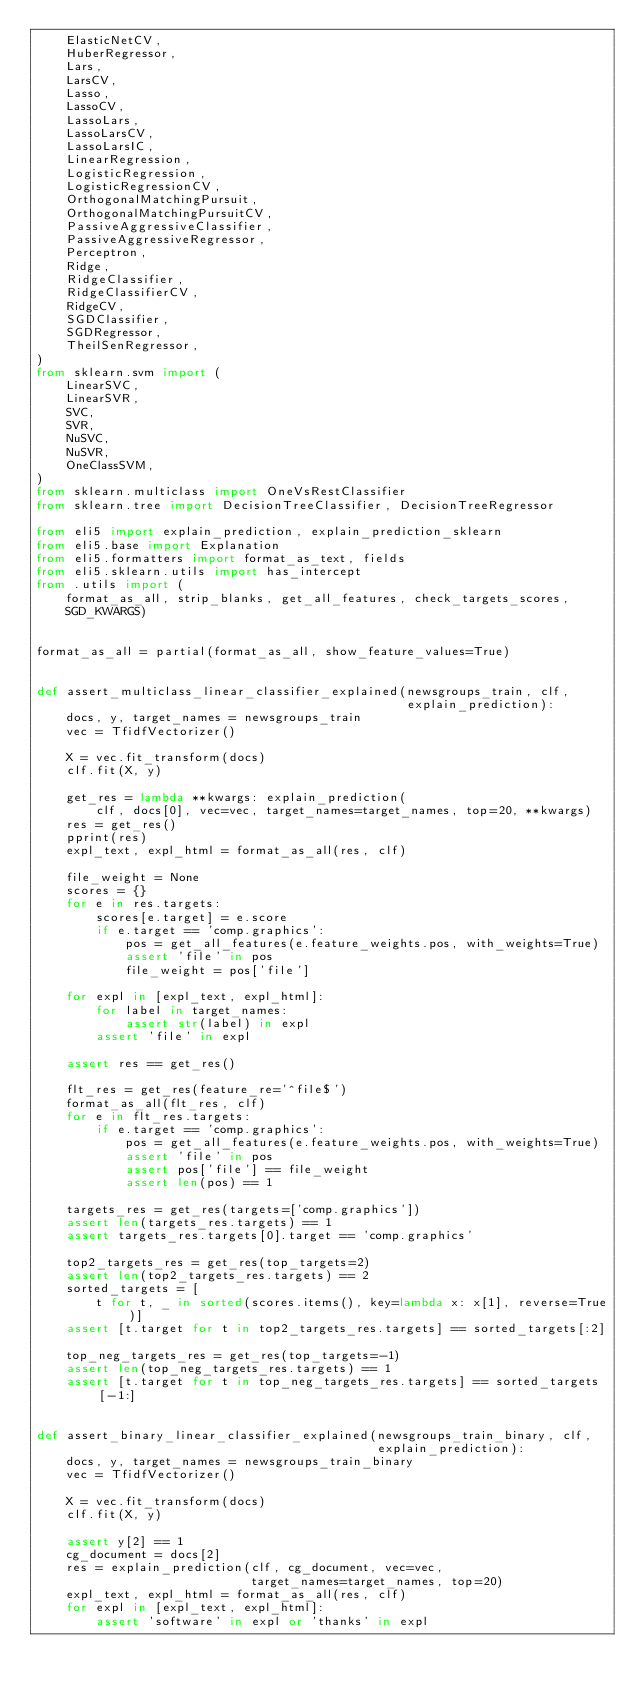<code> <loc_0><loc_0><loc_500><loc_500><_Python_>    ElasticNetCV,
    HuberRegressor,
    Lars,
    LarsCV,
    Lasso,
    LassoCV,
    LassoLars,
    LassoLarsCV,
    LassoLarsIC,
    LinearRegression,
    LogisticRegression,
    LogisticRegressionCV,
    OrthogonalMatchingPursuit,
    OrthogonalMatchingPursuitCV,
    PassiveAggressiveClassifier,
    PassiveAggressiveRegressor,
    Perceptron,
    Ridge,
    RidgeClassifier,
    RidgeClassifierCV,
    RidgeCV,
    SGDClassifier,
    SGDRegressor,
    TheilSenRegressor,
)
from sklearn.svm import (
    LinearSVC,
    LinearSVR,
    SVC,
    SVR,
    NuSVC,
    NuSVR,
    OneClassSVM,
)
from sklearn.multiclass import OneVsRestClassifier
from sklearn.tree import DecisionTreeClassifier, DecisionTreeRegressor

from eli5 import explain_prediction, explain_prediction_sklearn
from eli5.base import Explanation
from eli5.formatters import format_as_text, fields
from eli5.sklearn.utils import has_intercept
from .utils import (
    format_as_all, strip_blanks, get_all_features, check_targets_scores,
    SGD_KWARGS)


format_as_all = partial(format_as_all, show_feature_values=True)


def assert_multiclass_linear_classifier_explained(newsgroups_train, clf,
                                                  explain_prediction):
    docs, y, target_names = newsgroups_train
    vec = TfidfVectorizer()

    X = vec.fit_transform(docs)
    clf.fit(X, y)

    get_res = lambda **kwargs: explain_prediction(
        clf, docs[0], vec=vec, target_names=target_names, top=20, **kwargs)
    res = get_res()
    pprint(res)
    expl_text, expl_html = format_as_all(res, clf)

    file_weight = None
    scores = {}
    for e in res.targets:
        scores[e.target] = e.score
        if e.target == 'comp.graphics':
            pos = get_all_features(e.feature_weights.pos, with_weights=True)
            assert 'file' in pos
            file_weight = pos['file']

    for expl in [expl_text, expl_html]:
        for label in target_names:
            assert str(label) in expl
        assert 'file' in expl

    assert res == get_res()

    flt_res = get_res(feature_re='^file$')
    format_as_all(flt_res, clf)
    for e in flt_res.targets:
        if e.target == 'comp.graphics':
            pos = get_all_features(e.feature_weights.pos, with_weights=True)
            assert 'file' in pos
            assert pos['file'] == file_weight
            assert len(pos) == 1

    targets_res = get_res(targets=['comp.graphics'])
    assert len(targets_res.targets) == 1
    assert targets_res.targets[0].target == 'comp.graphics'

    top2_targets_res = get_res(top_targets=2)
    assert len(top2_targets_res.targets) == 2
    sorted_targets = [
        t for t, _ in sorted(scores.items(), key=lambda x: x[1], reverse=True)]
    assert [t.target for t in top2_targets_res.targets] == sorted_targets[:2]

    top_neg_targets_res = get_res(top_targets=-1)
    assert len(top_neg_targets_res.targets) == 1
    assert [t.target for t in top_neg_targets_res.targets] == sorted_targets[-1:]


def assert_binary_linear_classifier_explained(newsgroups_train_binary, clf,
                                              explain_prediction):
    docs, y, target_names = newsgroups_train_binary
    vec = TfidfVectorizer()

    X = vec.fit_transform(docs)
    clf.fit(X, y)

    assert y[2] == 1
    cg_document = docs[2]
    res = explain_prediction(clf, cg_document, vec=vec,
                             target_names=target_names, top=20)
    expl_text, expl_html = format_as_all(res, clf)
    for expl in [expl_text, expl_html]:
        assert 'software' in expl or 'thanks' in expl</code> 